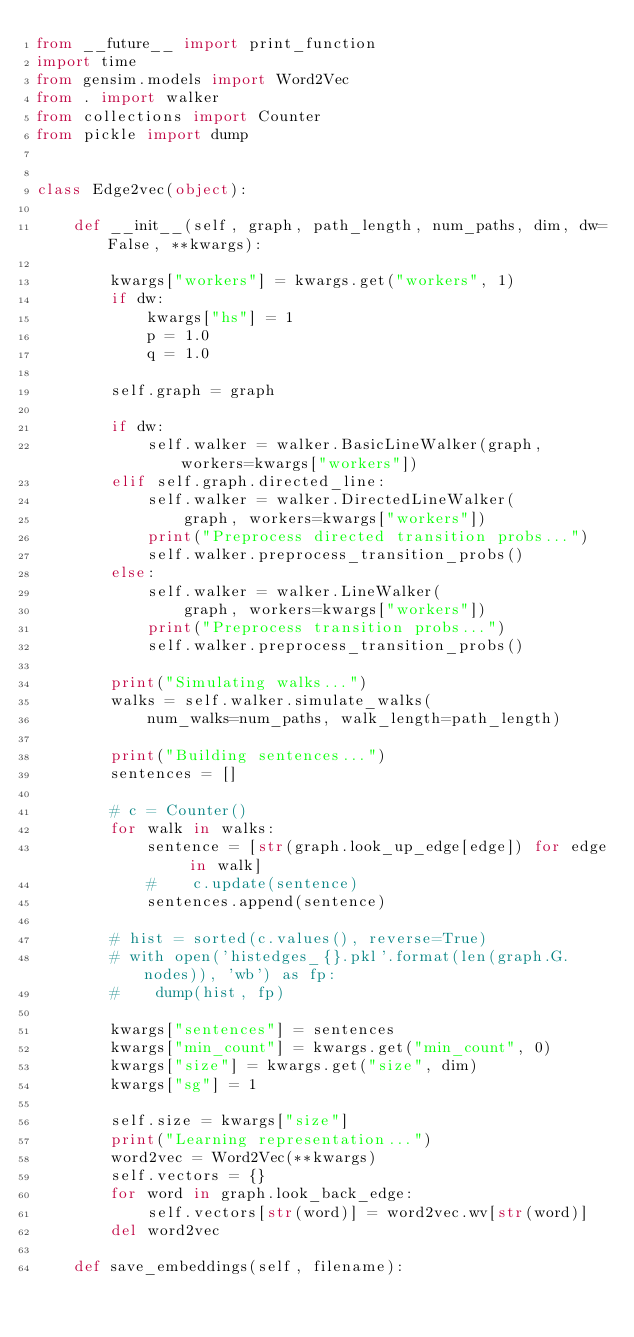Convert code to text. <code><loc_0><loc_0><loc_500><loc_500><_Python_>from __future__ import print_function
import time
from gensim.models import Word2Vec
from . import walker
from collections import Counter
from pickle import dump


class Edge2vec(object):

    def __init__(self, graph, path_length, num_paths, dim, dw=False, **kwargs):

        kwargs["workers"] = kwargs.get("workers", 1)
        if dw:
            kwargs["hs"] = 1
            p = 1.0
            q = 1.0

        self.graph = graph

        if dw:
            self.walker = walker.BasicLineWalker(graph, workers=kwargs["workers"])
        elif self.graph.directed_line:
            self.walker = walker.DirectedLineWalker(
                graph, workers=kwargs["workers"])
            print("Preprocess directed transition probs...")
            self.walker.preprocess_transition_probs()
        else:
            self.walker = walker.LineWalker(
                graph, workers=kwargs["workers"])
            print("Preprocess transition probs...")
            self.walker.preprocess_transition_probs()

        print("Simulating walks...")
        walks = self.walker.simulate_walks(
            num_walks=num_paths, walk_length=path_length)

        print("Building sentences...")
        sentences = []

        # c = Counter()
        for walk in walks:
            sentence = [str(graph.look_up_edge[edge]) for edge in walk]
            #    c.update(sentence)
            sentences.append(sentence)

        # hist = sorted(c.values(), reverse=True)
        # with open('histedges_{}.pkl'.format(len(graph.G.nodes)), 'wb') as fp:
        #    dump(hist, fp)

        kwargs["sentences"] = sentences
        kwargs["min_count"] = kwargs.get("min_count", 0)
        kwargs["size"] = kwargs.get("size", dim)
        kwargs["sg"] = 1

        self.size = kwargs["size"]
        print("Learning representation...")
        word2vec = Word2Vec(**kwargs)
        self.vectors = {}
        for word in graph.look_back_edge:
            self.vectors[str(word)] = word2vec.wv[str(word)]
        del word2vec

    def save_embeddings(self, filename):</code> 